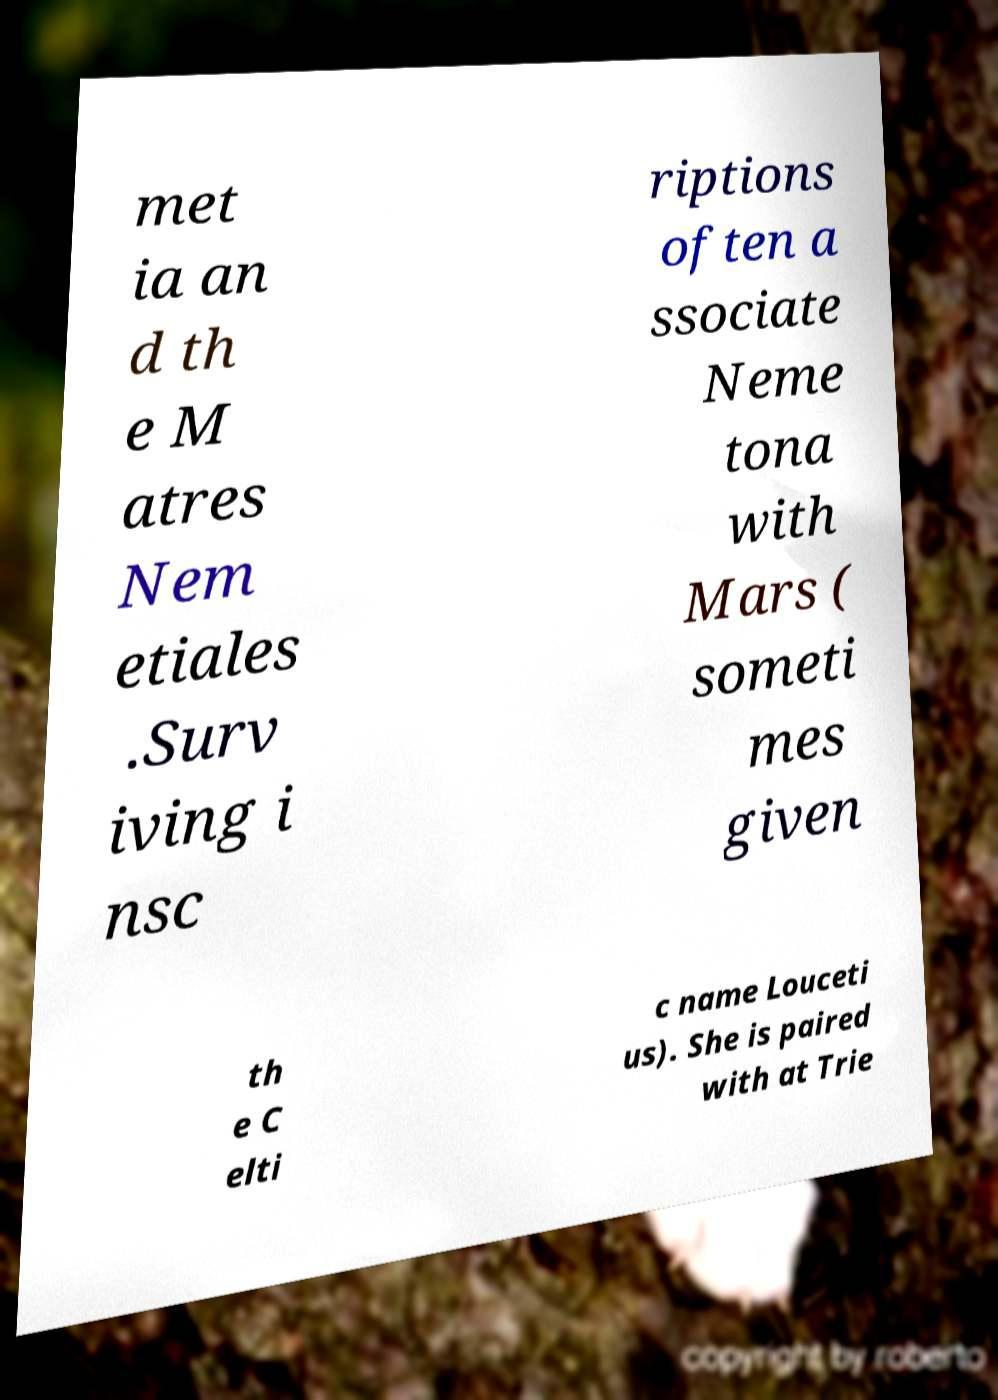For documentation purposes, I need the text within this image transcribed. Could you provide that? met ia an d th e M atres Nem etiales .Surv iving i nsc riptions often a ssociate Neme tona with Mars ( someti mes given th e C elti c name Louceti us). She is paired with at Trie 